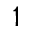Convert formula to latex. <formula><loc_0><loc_0><loc_500><loc_500>^ { 1 }</formula> 